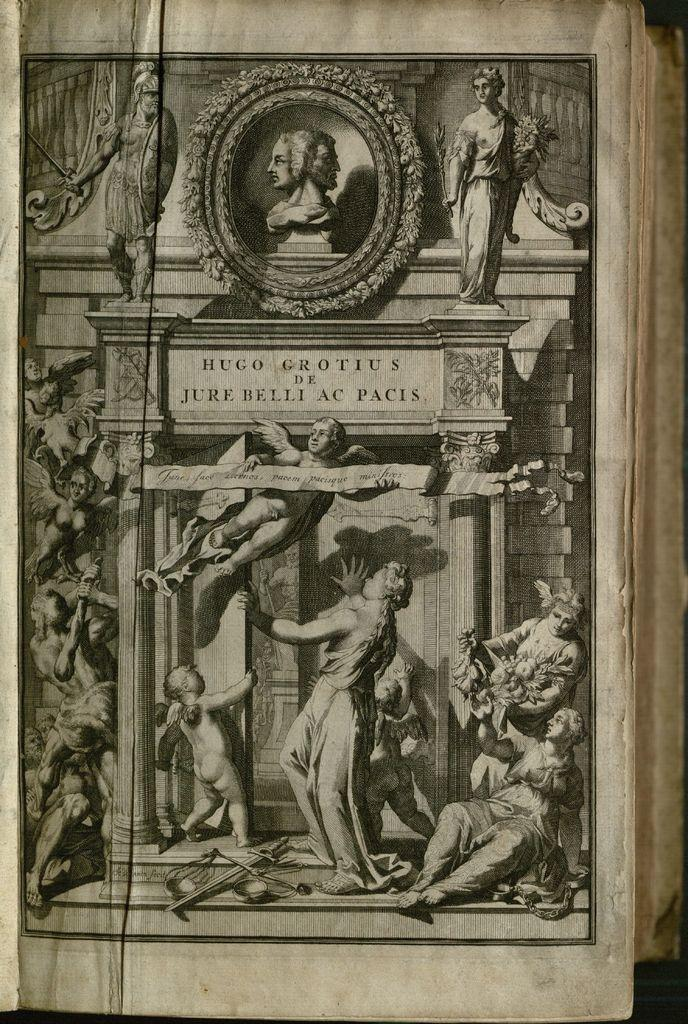What type of item is the image used for? The image is a cover page of a book. What is depicted in the painting on the cover page? There is a painting of people with wings on the cover page. What else can be found on the cover page besides the painting? There are texts on the cover page. What other object is shown on the cover page? There is a statue depicted on the cover page. How many babies are shown in the painting on the cover page? There are no babies depicted in the painting on the cover page; it features people with wings. What type of tooth is shown in the painting on the cover page? There is no tooth present in the painting on the cover page; it features people with wings and a statue. 